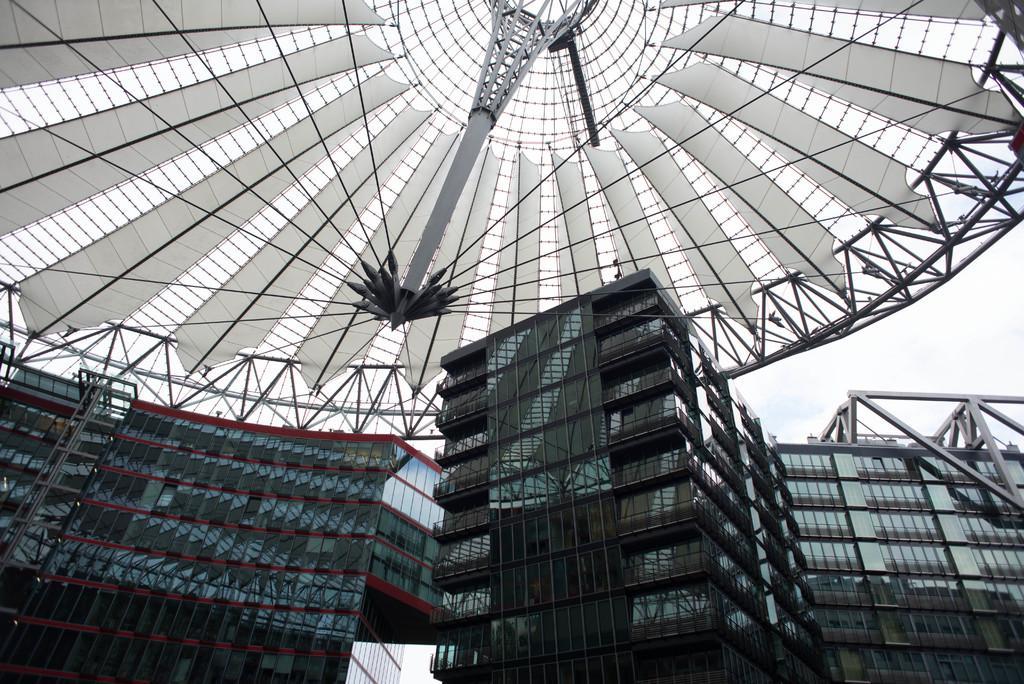Could you give a brief overview of what you see in this image? In the foreground of the picture there are buildings with glass windows. At the top it is ceiling with iron frames and glasses. On the right we can see sky. 